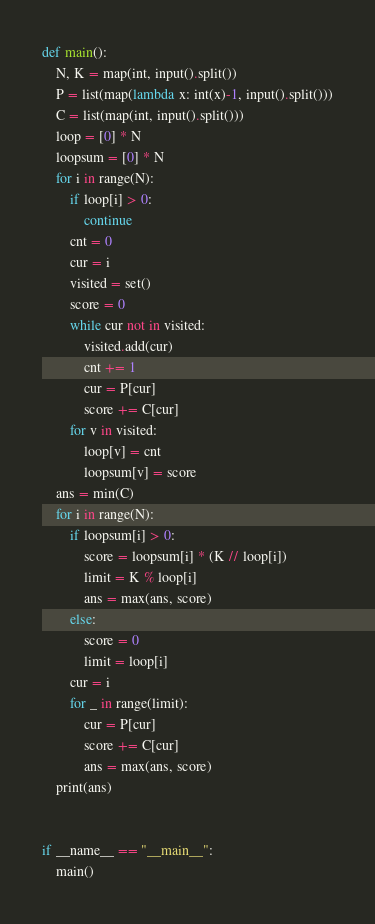<code> <loc_0><loc_0><loc_500><loc_500><_Python_>def main():
    N, K = map(int, input().split())
    P = list(map(lambda x: int(x)-1, input().split()))
    C = list(map(int, input().split()))
    loop = [0] * N
    loopsum = [0] * N
    for i in range(N):
        if loop[i] > 0:
            continue
        cnt = 0
        cur = i
        visited = set()
        score = 0
        while cur not in visited:
            visited.add(cur)
            cnt += 1
            cur = P[cur]
            score += C[cur]
        for v in visited:
            loop[v] = cnt
            loopsum[v] = score
    ans = min(C)
    for i in range(N):
        if loopsum[i] > 0:
            score = loopsum[i] * (K // loop[i])
            limit = K % loop[i]
            ans = max(ans, score)
        else:
            score = 0
            limit = loop[i]
        cur = i
        for _ in range(limit):
            cur = P[cur]
            score += C[cur]
            ans = max(ans, score)
    print(ans)


if __name__ == "__main__":
    main()
</code> 